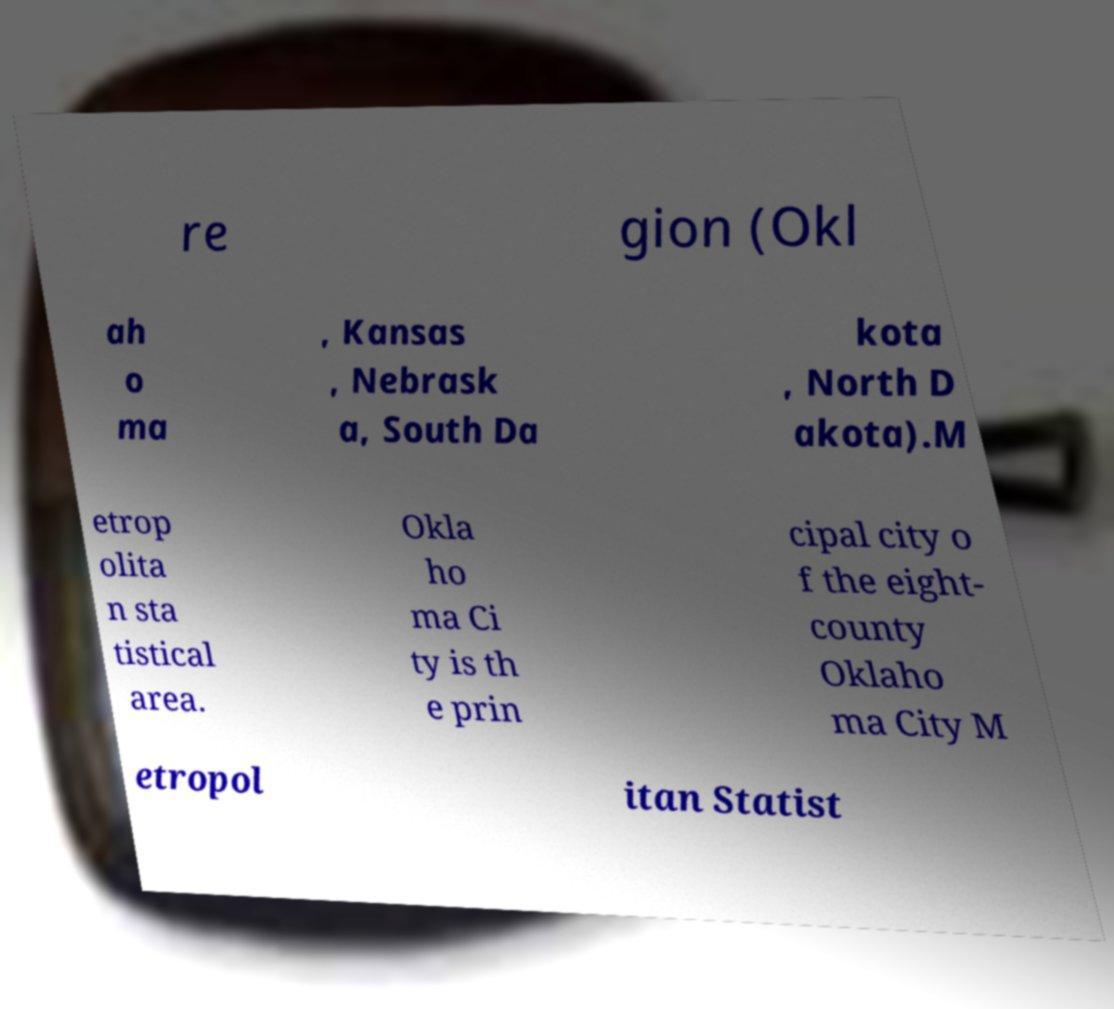Could you extract and type out the text from this image? re gion (Okl ah o ma , Kansas , Nebrask a, South Da kota , North D akota).M etrop olita n sta tistical area. Okla ho ma Ci ty is th e prin cipal city o f the eight- county Oklaho ma City M etropol itan Statist 